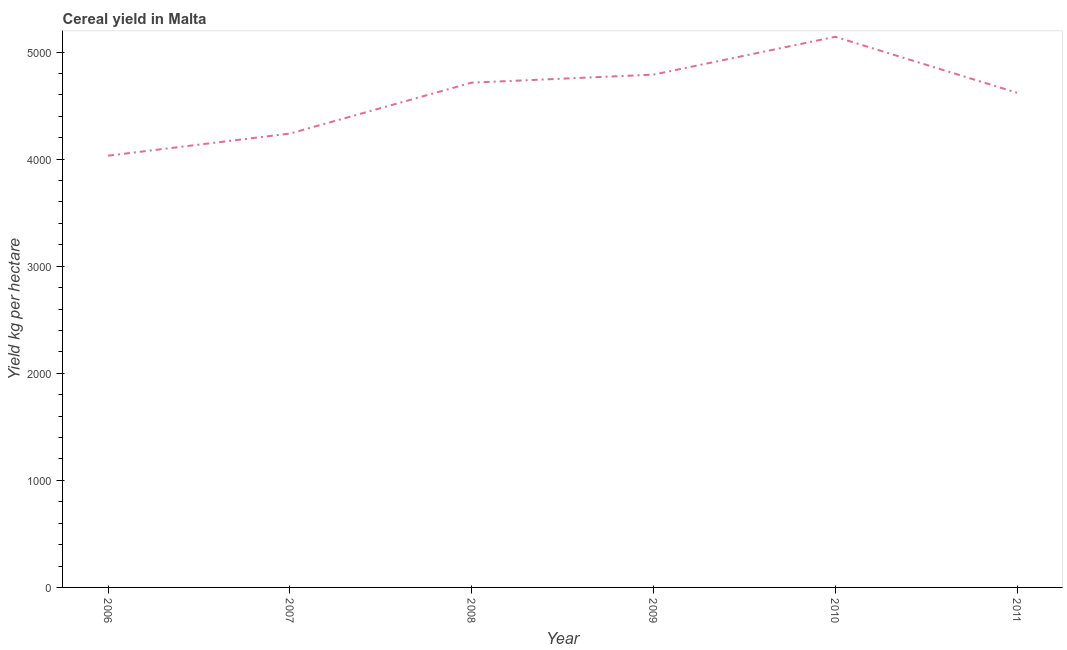What is the cereal yield in 2006?
Ensure brevity in your answer.  4032.26. Across all years, what is the maximum cereal yield?
Ensure brevity in your answer.  5142.86. Across all years, what is the minimum cereal yield?
Your response must be concise. 4032.26. In which year was the cereal yield minimum?
Offer a terse response. 2006. What is the sum of the cereal yield?
Provide a short and direct response. 2.75e+04. What is the difference between the cereal yield in 2006 and 2011?
Give a very brief answer. -587.62. What is the average cereal yield per year?
Your response must be concise. 4589.54. What is the median cereal yield?
Offer a terse response. 4667.08. Do a majority of the years between 2006 and 2008 (inclusive) have cereal yield greater than 3200 kg per hectare?
Provide a short and direct response. Yes. What is the ratio of the cereal yield in 2007 to that in 2011?
Give a very brief answer. 0.92. Is the difference between the cereal yield in 2007 and 2011 greater than the difference between any two years?
Ensure brevity in your answer.  No. What is the difference between the highest and the second highest cereal yield?
Your answer should be compact. 353.7. Is the sum of the cereal yield in 2006 and 2007 greater than the maximum cereal yield across all years?
Your response must be concise. Yes. What is the difference between the highest and the lowest cereal yield?
Your answer should be compact. 1110.6. Does the cereal yield monotonically increase over the years?
Provide a succinct answer. No. How many years are there in the graph?
Your answer should be compact. 6. What is the difference between two consecutive major ticks on the Y-axis?
Provide a short and direct response. 1000. Are the values on the major ticks of Y-axis written in scientific E-notation?
Offer a terse response. No. Does the graph contain any zero values?
Provide a short and direct response. No. Does the graph contain grids?
Your answer should be compact. No. What is the title of the graph?
Give a very brief answer. Cereal yield in Malta. What is the label or title of the X-axis?
Your answer should be very brief. Year. What is the label or title of the Y-axis?
Ensure brevity in your answer.  Yield kg per hectare. What is the Yield kg per hectare in 2006?
Your answer should be compact. 4032.26. What is the Yield kg per hectare in 2007?
Your answer should be very brief. 4238.81. What is the Yield kg per hectare in 2008?
Offer a terse response. 4714.29. What is the Yield kg per hectare of 2009?
Give a very brief answer. 4789.16. What is the Yield kg per hectare in 2010?
Provide a short and direct response. 5142.86. What is the Yield kg per hectare of 2011?
Offer a very short reply. 4619.88. What is the difference between the Yield kg per hectare in 2006 and 2007?
Provide a succinct answer. -206.55. What is the difference between the Yield kg per hectare in 2006 and 2008?
Ensure brevity in your answer.  -682.03. What is the difference between the Yield kg per hectare in 2006 and 2009?
Provide a short and direct response. -756.9. What is the difference between the Yield kg per hectare in 2006 and 2010?
Give a very brief answer. -1110.6. What is the difference between the Yield kg per hectare in 2006 and 2011?
Offer a very short reply. -587.62. What is the difference between the Yield kg per hectare in 2007 and 2008?
Your answer should be compact. -475.48. What is the difference between the Yield kg per hectare in 2007 and 2009?
Your response must be concise. -550.35. What is the difference between the Yield kg per hectare in 2007 and 2010?
Give a very brief answer. -904.05. What is the difference between the Yield kg per hectare in 2007 and 2011?
Ensure brevity in your answer.  -381.08. What is the difference between the Yield kg per hectare in 2008 and 2009?
Keep it short and to the point. -74.87. What is the difference between the Yield kg per hectare in 2008 and 2010?
Make the answer very short. -428.57. What is the difference between the Yield kg per hectare in 2008 and 2011?
Make the answer very short. 94.4. What is the difference between the Yield kg per hectare in 2009 and 2010?
Ensure brevity in your answer.  -353.7. What is the difference between the Yield kg per hectare in 2009 and 2011?
Keep it short and to the point. 169.27. What is the difference between the Yield kg per hectare in 2010 and 2011?
Your answer should be compact. 522.97. What is the ratio of the Yield kg per hectare in 2006 to that in 2007?
Provide a succinct answer. 0.95. What is the ratio of the Yield kg per hectare in 2006 to that in 2008?
Ensure brevity in your answer.  0.85. What is the ratio of the Yield kg per hectare in 2006 to that in 2009?
Your answer should be very brief. 0.84. What is the ratio of the Yield kg per hectare in 2006 to that in 2010?
Give a very brief answer. 0.78. What is the ratio of the Yield kg per hectare in 2006 to that in 2011?
Ensure brevity in your answer.  0.87. What is the ratio of the Yield kg per hectare in 2007 to that in 2008?
Give a very brief answer. 0.9. What is the ratio of the Yield kg per hectare in 2007 to that in 2009?
Give a very brief answer. 0.89. What is the ratio of the Yield kg per hectare in 2007 to that in 2010?
Provide a short and direct response. 0.82. What is the ratio of the Yield kg per hectare in 2007 to that in 2011?
Keep it short and to the point. 0.92. What is the ratio of the Yield kg per hectare in 2008 to that in 2009?
Keep it short and to the point. 0.98. What is the ratio of the Yield kg per hectare in 2008 to that in 2010?
Ensure brevity in your answer.  0.92. What is the ratio of the Yield kg per hectare in 2008 to that in 2011?
Your answer should be very brief. 1.02. What is the ratio of the Yield kg per hectare in 2009 to that in 2010?
Your response must be concise. 0.93. What is the ratio of the Yield kg per hectare in 2009 to that in 2011?
Keep it short and to the point. 1.04. What is the ratio of the Yield kg per hectare in 2010 to that in 2011?
Provide a succinct answer. 1.11. 